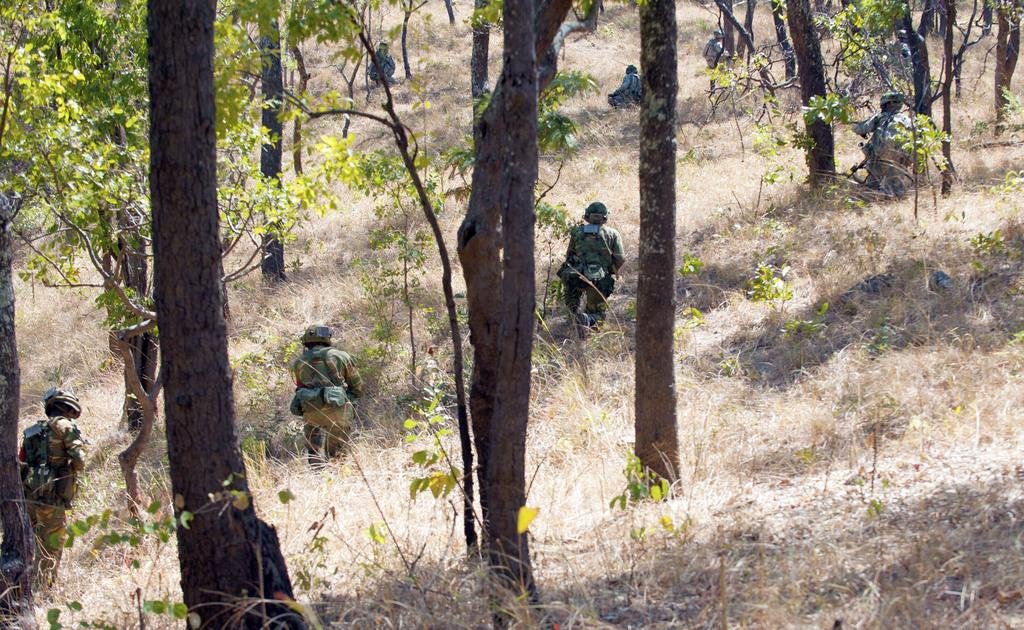What type of people are present in the image? There are soldiers in the image. What is the ground surface like in the image? There is grass on the ground in the image. What type of vegetation can be seen in the image? There are trees visible in the image. What type of comb is being used by the parent in the image? There is no parent or comb present in the image; it features soldiers and natural elements. 